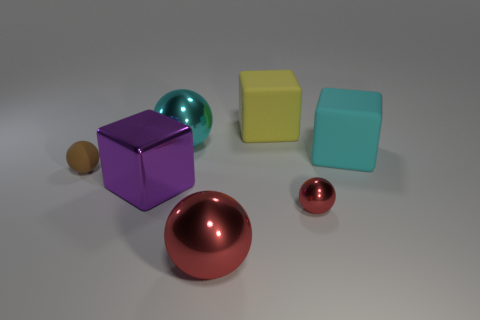Add 1 small yellow matte objects. How many objects exist? 8 Subtract all cubes. How many objects are left? 4 Add 5 tiny brown matte balls. How many tiny brown matte balls exist? 6 Subtract 0 yellow cylinders. How many objects are left? 7 Subtract all big rubber things. Subtract all shiny spheres. How many objects are left? 2 Add 6 tiny rubber balls. How many tiny rubber balls are left? 7 